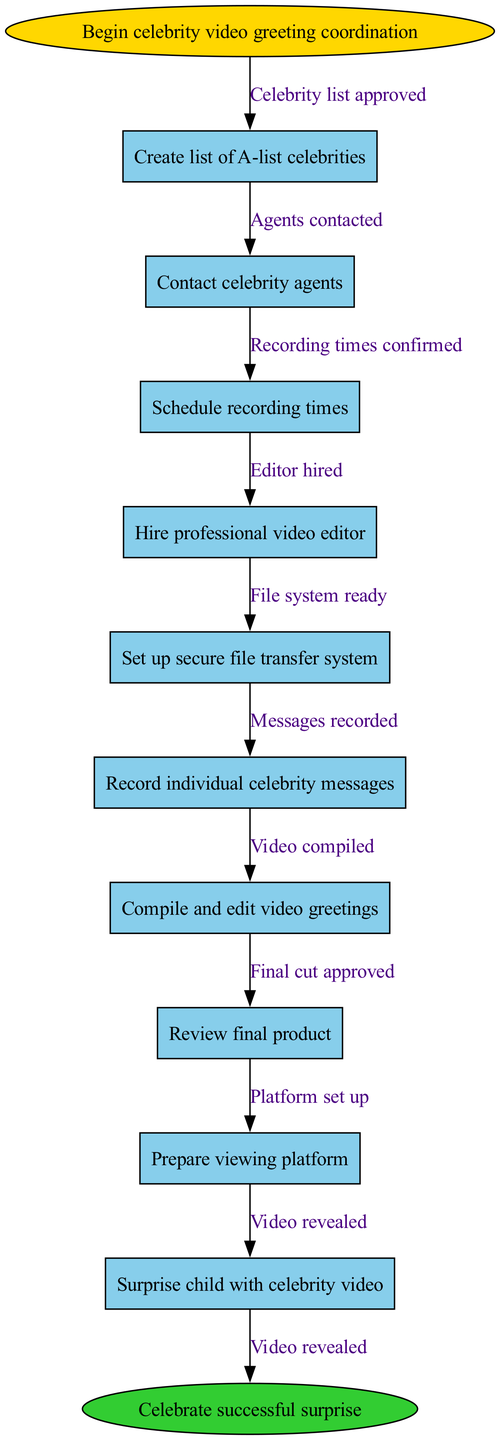What is the first step in coordinating the surprise? The first step, indicated at the beginning of the diagram, is labeled "Begin celebrity video greeting coordination." This initiates the overall process of gathering celebrity greetings.
Answer: Begin celebrity video greeting coordination How many nodes are present in the diagram? By counting each individual task or step detailed within the nodes, we find there are eleven nodes in total: one start node, nine main nodes, and one end node.
Answer: Eleven What is the last action before celebrating the surprise? The last action before reaching the end of the process is "Surprise child with celebrity video." This concludes the series of tasks leading to the celebration.
Answer: Surprise child with celebrity video What follows after "Record individual celebrity messages"? After "Record individual celebrity messages," the following step in the flowchart is "Compile and edit video greetings," which is the next logical step in processing the recorded messages.
Answer: Compile and edit video greetings How many edges connect the nodes in the diagram? Each node is connected by edges, and since there are eleven nodes, there are ten edges corresponding to the transitions between each step in the process.
Answer: Ten What is indicated by the edge from "Set up secure file transfer system" to "Record individual celebrity messages"? This edge indicates that once the secure file transfer system is successfully established, the next action is to proceed to record individual celebrity messages. It shows a sequential flow after the setup task.
Answer: Record individual celebrity messages Which node involves hiring a professional? The node "Hire professional video editor" is specifically dedicated to the action of hiring a professional, indicating that this task is essential for ensuring high-quality video production.
Answer: Hire professional video editor What is the second node in the sequence? The second node in the diagram is "Contact celebrity agents," which follows the initial step of beginning the coordination process. It sets up important communications for the subsequent tasks.
Answer: Contact celebrity agents What do we do after confirming recording times? After confirming recording times, the next action in the flowchart is to "Hire professional video editor," indicating the need to secure editing talent before the recordings are made.
Answer: Hire professional video editor What type of diagram is used in this coordination process? The diagram used in this coordination process is a programming flowchart, which outlines a series of steps and decisions in a linear format to achieve a specific outcome.
Answer: Programming flowchart 